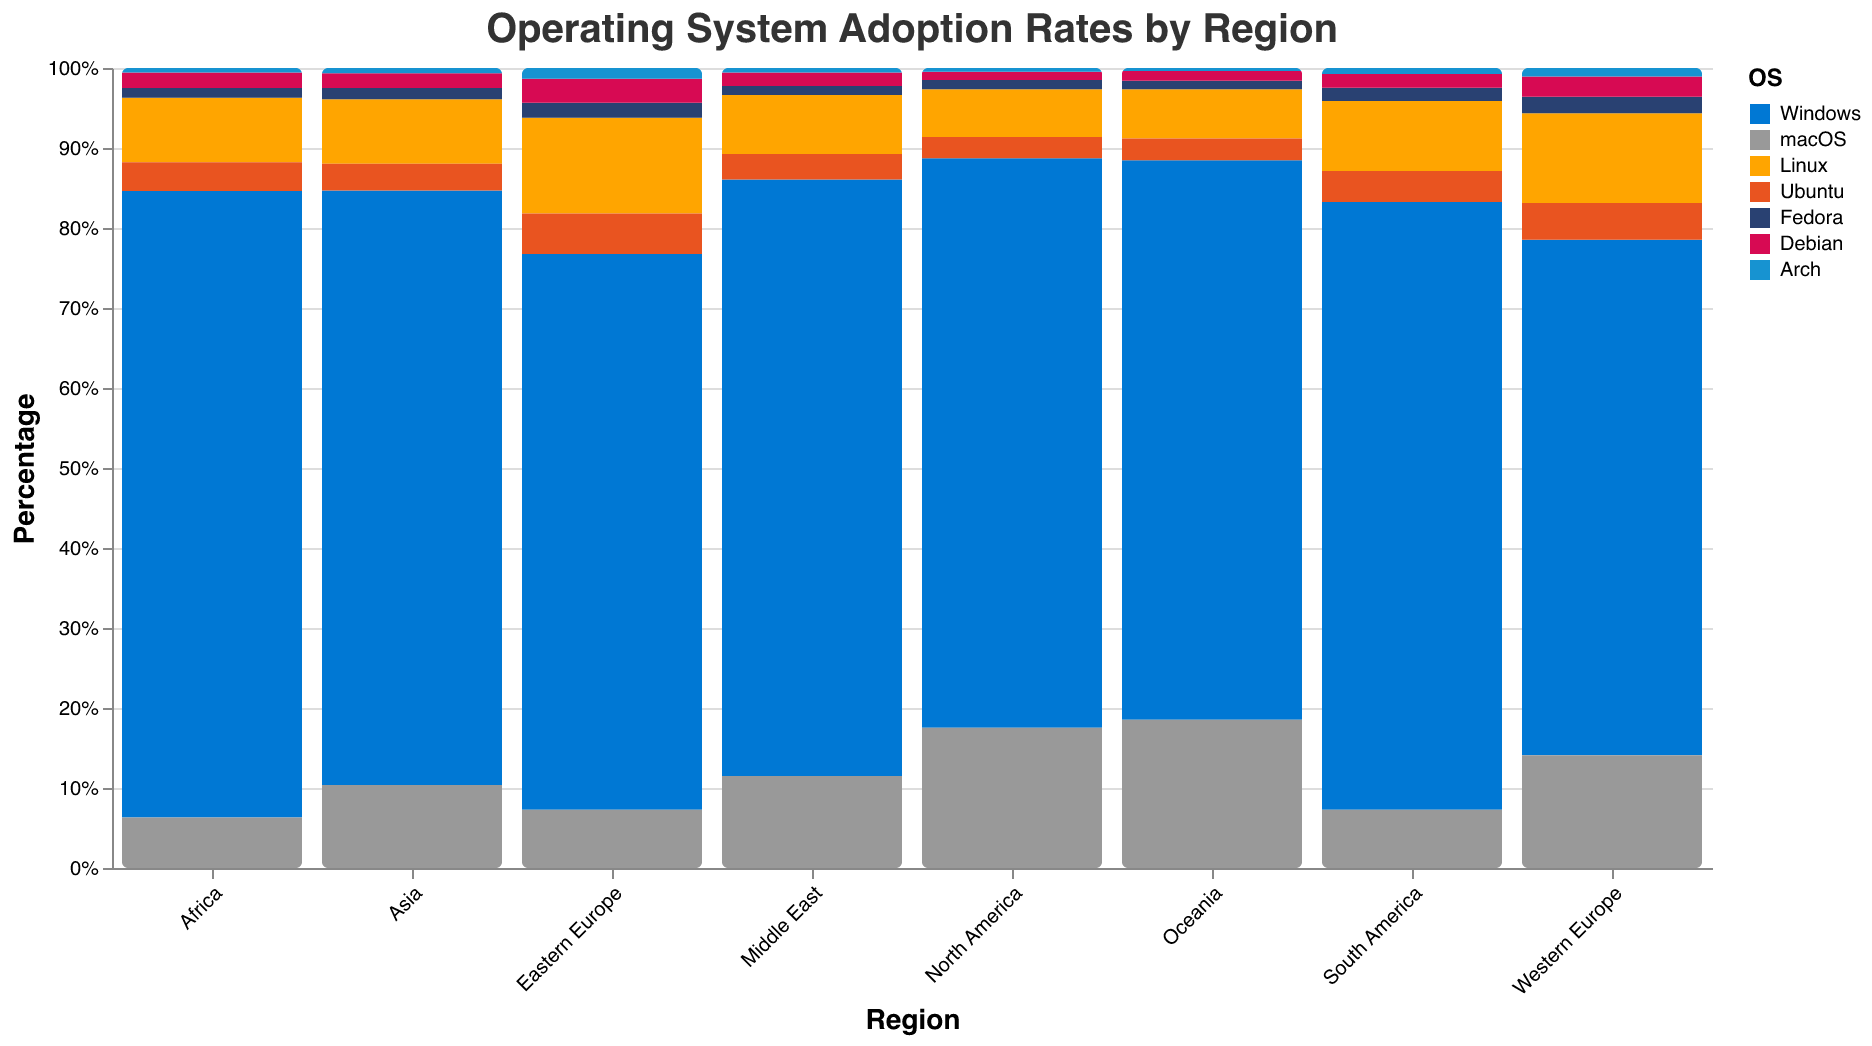What is the title of the chart? The title is prominently displayed at the top of the chart and generally provides a clear and concise summary of what the chart is about. In this case, the title explicitly mentions the key elements of the chart.
Answer: Operating System Adoption Rates by Region Which region has the highest percentage of Linux adoption? To find this, look for the segment representing Linux in each region's bar and compare their sizes. The data reveals Eastern Europe has the largest segment for Linux.
Answer: Eastern Europe What is the total market share of Windows and macOS combined in North America? Add the percentages for Windows and macOS in North America: 75.2 + 18.5
Answer: 93.7% Which Linux distribution has the highest adoption rate in Western Europe? Compare the segments within the 'Linux' category specific to Western Europe. Identify the segment with the largest percentage.
Answer: Ubuntu What is the difference in Linux adoption rates between Africa and Asia? Subtract the Linux adoption rate in Asia (8.7) from that in Africa (8.7). Both rates are the same.
Answer: 0% Which region has the lowest percentage of macOS users, and what is that percentage? Compare the macOS segments across all regions and find the smallest. Here, Africa has the lowest macOS adoption.
Answer: Africa, 6.8% Is the adoption rate of Fedora higher in South America or Eastern Europe? Check the Fedora segments in both regions and compare their percentages. South America has a Fedora rate of 1.8%, while Eastern Europe has 2.1%.
Answer: Eastern Europe What is the average uptake of Linux across all regions? Add the Linux adoption rates for all regions and divide by the number of regions (8 regions). The sum of the percentages is \(6.3 + 12.5 + 13.5 + 9.5 + 8.7 + 8.7 + 6.5 + 7.9\), which equals 73.6. Then divide by 8.
Answer: 9.2 Which region's adoption rate for Arch is closest to 1%? Compare the Arch segments across all regions to see which is nearest to 1%. Western Europe has an Arch rate of 1.2%, which is the closest to 1%.
Answer: Western Europe Does any region have an equal adoption rate for both Fedora and Debian? Compare the Fedora and Debian segments within each region to see if they match. No region has equal rates for Fedora and Debian.
Answer: No 